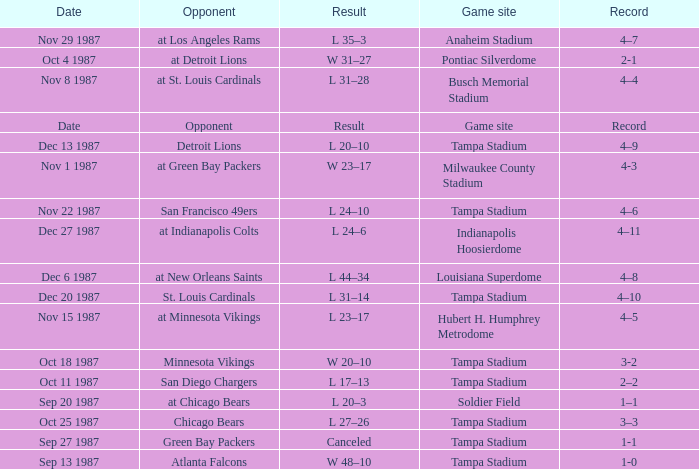Who was the Opponent at the Game Site Indianapolis Hoosierdome? At indianapolis colts. 